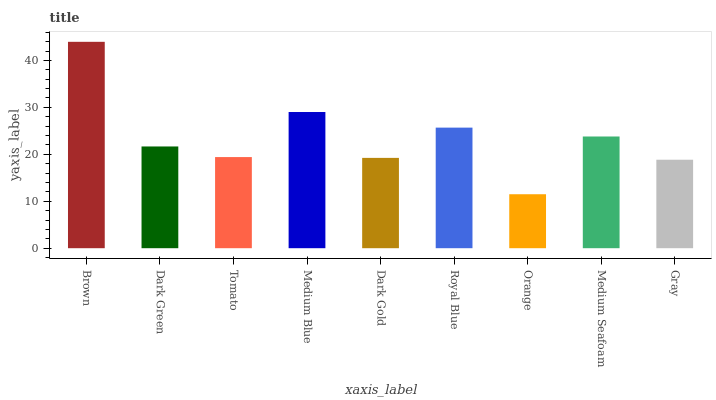Is Orange the minimum?
Answer yes or no. Yes. Is Brown the maximum?
Answer yes or no. Yes. Is Dark Green the minimum?
Answer yes or no. No. Is Dark Green the maximum?
Answer yes or no. No. Is Brown greater than Dark Green?
Answer yes or no. Yes. Is Dark Green less than Brown?
Answer yes or no. Yes. Is Dark Green greater than Brown?
Answer yes or no. No. Is Brown less than Dark Green?
Answer yes or no. No. Is Dark Green the high median?
Answer yes or no. Yes. Is Dark Green the low median?
Answer yes or no. Yes. Is Brown the high median?
Answer yes or no. No. Is Dark Gold the low median?
Answer yes or no. No. 